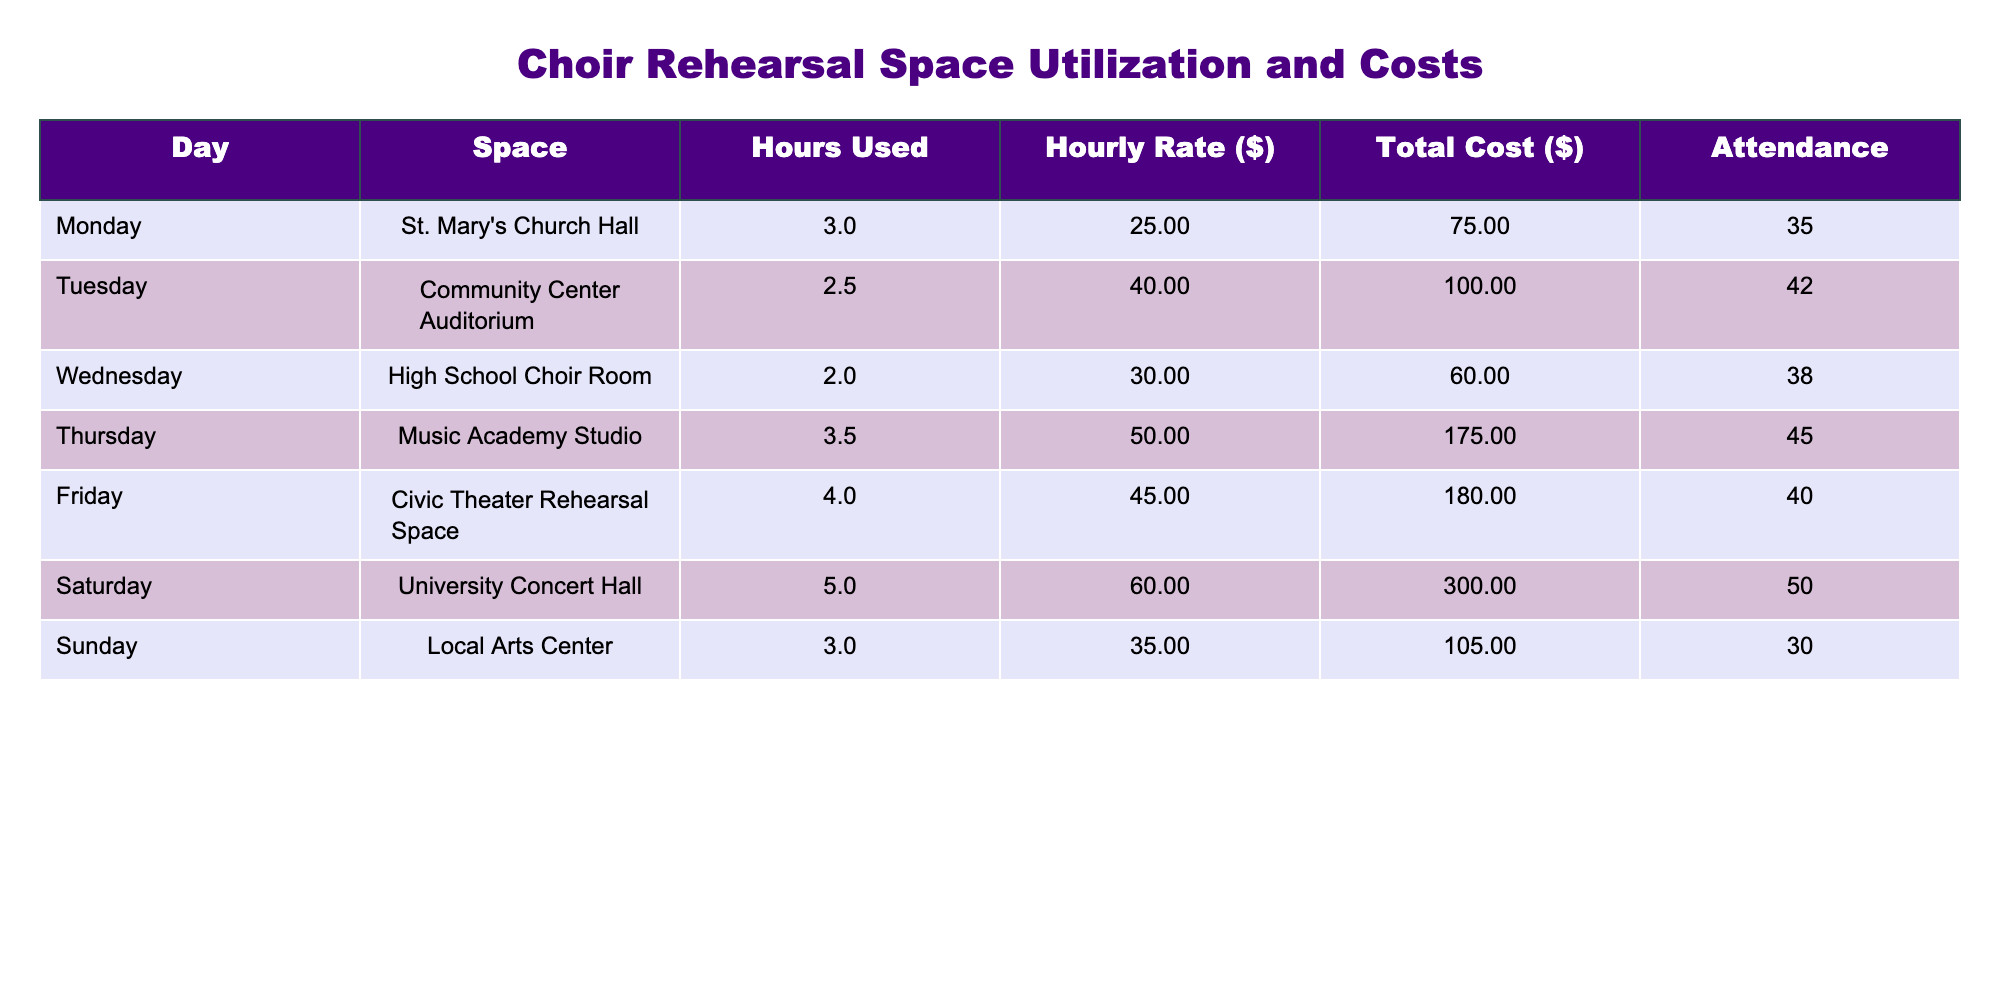What is the total cost of choir space rental on Saturday? The total cost for Saturday is directly listed in the table as $300.
Answer: 300 What day had the highest attendance? By comparing the attendance values for each day listed in the table, Saturday shows the highest attendance at 50 people.
Answer: Saturday What is the average hourly rate for all spaces used? The hourly rates are 25, 40, 30, 50, 45, 60, and 35. Adding these together gives (25 + 40 + 30 + 50 + 45 + 60 + 35) = 285. There are 7 days, so the average is 285/7 ≈ 40.71.
Answer: Approximately 40.71 Did the space with the highest total cost have the highest hourly rate? The space with the highest total cost is Saturday's University Concert Hall at $300, and the highest hourly rate is also on Saturday at $60. Since both are for Saturday, the answer is yes.
Answer: Yes What percentage of the total weekly costs does the Civic Theater Rehearsal Space account for? First, we calculate the total weekly cost: 75 + 100 + 60 + 175 + 180 + 300 + 105 = 1025. The Civic Theater Rehearsal Space cost is $180. To find the percentage, calculate (180/1025) * 100 ≈ 17.56%.
Answer: Approximately 17.56% Which day had the least space used in hours? By reviewing the hours used for each day, Tuesday had the least space used at 2.5 hours.
Answer: Tuesday If attendance on Friday increased by 10%, what would the new attendance number be? The original attendance on Friday is 40. An increase of 10% would be calculated by taking 10% of 40, which is 4. Adding this to the original attendance gives 40 + 4 = 44.
Answer: 44 What is the total number of hours used for rehearsals throughout the week? By adding the hours used for each day: 3 + 2.5 + 2 + 3.5 + 4 + 5 + 3 = 23.
Answer: 23 Is the hourly rate for St. Mary's Church Hall lower than the average hourly rate? The hourly rate for St. Mary's Church Hall is $25. The average hourly rate calculated earlier is approximately $40.71, and since $25 is lower than $40.71, the answer is yes.
Answer: Yes What is the difference in total cost between the highest and lowest cost days? The highest total cost is $300 (Saturday), and the lowest is $60 (Wednesday). The difference is 300 - 60 = 240.
Answer: 240 